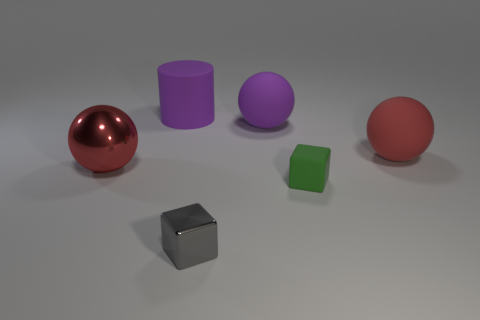There is a metal object that is in front of the large red metallic thing; is it the same color as the big matte thing in front of the large purple matte ball?
Your answer should be compact. No. Are there any other tiny green things that have the same material as the green object?
Provide a succinct answer. No. What is the color of the large shiny thing?
Keep it short and to the point. Red. What size is the cube that is on the right side of the large purple thing that is on the right side of the purple matte object that is to the left of the big purple ball?
Offer a very short reply. Small. How many other objects are there of the same shape as the small rubber thing?
Offer a very short reply. 1. What color is the thing that is in front of the purple rubber sphere and behind the metallic ball?
Provide a succinct answer. Red. There is a rubber sphere to the left of the rubber cube; is its color the same as the big cylinder?
Keep it short and to the point. Yes. How many blocks are either tiny metallic objects or big red rubber objects?
Your answer should be very brief. 1. There is a big red thing that is to the left of the red matte ball; what is its shape?
Give a very brief answer. Sphere. What color is the large rubber ball that is behind the large red ball to the right of the large red object to the left of the green matte cube?
Your response must be concise. Purple. 